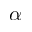Convert formula to latex. <formula><loc_0><loc_0><loc_500><loc_500>\alpha</formula> 